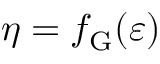<formula> <loc_0><loc_0><loc_500><loc_500>\eta = f _ { G } ( \varepsilon )</formula> 